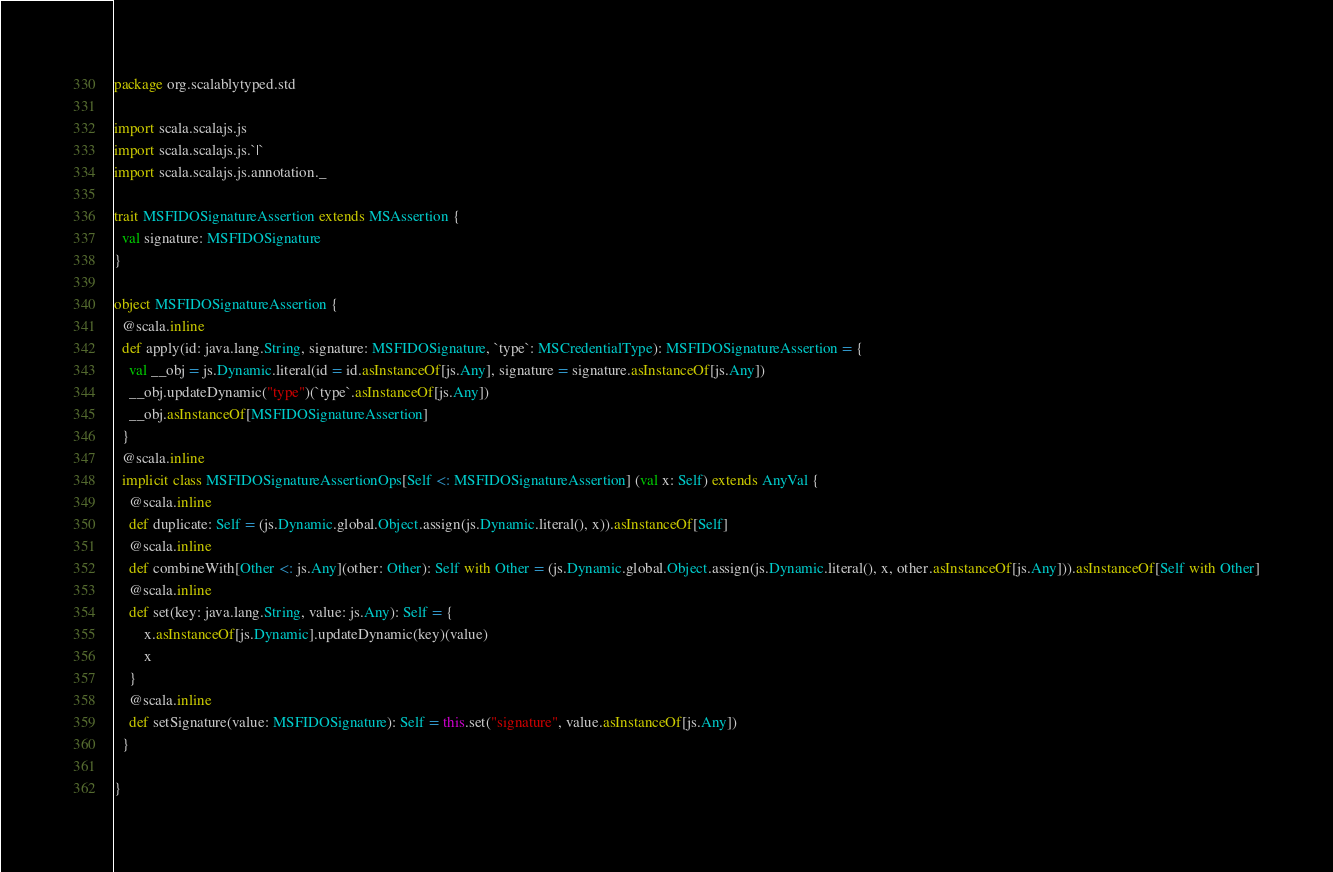Convert code to text. <code><loc_0><loc_0><loc_500><loc_500><_Scala_>package org.scalablytyped.std

import scala.scalajs.js
import scala.scalajs.js.`|`
import scala.scalajs.js.annotation._

trait MSFIDOSignatureAssertion extends MSAssertion {
  val signature: MSFIDOSignature
}

object MSFIDOSignatureAssertion {
  @scala.inline
  def apply(id: java.lang.String, signature: MSFIDOSignature, `type`: MSCredentialType): MSFIDOSignatureAssertion = {
    val __obj = js.Dynamic.literal(id = id.asInstanceOf[js.Any], signature = signature.asInstanceOf[js.Any])
    __obj.updateDynamic("type")(`type`.asInstanceOf[js.Any])
    __obj.asInstanceOf[MSFIDOSignatureAssertion]
  }
  @scala.inline
  implicit class MSFIDOSignatureAssertionOps[Self <: MSFIDOSignatureAssertion] (val x: Self) extends AnyVal {
    @scala.inline
    def duplicate: Self = (js.Dynamic.global.Object.assign(js.Dynamic.literal(), x)).asInstanceOf[Self]
    @scala.inline
    def combineWith[Other <: js.Any](other: Other): Self with Other = (js.Dynamic.global.Object.assign(js.Dynamic.literal(), x, other.asInstanceOf[js.Any])).asInstanceOf[Self with Other]
    @scala.inline
    def set(key: java.lang.String, value: js.Any): Self = {
        x.asInstanceOf[js.Dynamic].updateDynamic(key)(value)
        x
    }
    @scala.inline
    def setSignature(value: MSFIDOSignature): Self = this.set("signature", value.asInstanceOf[js.Any])
  }
  
}

</code> 